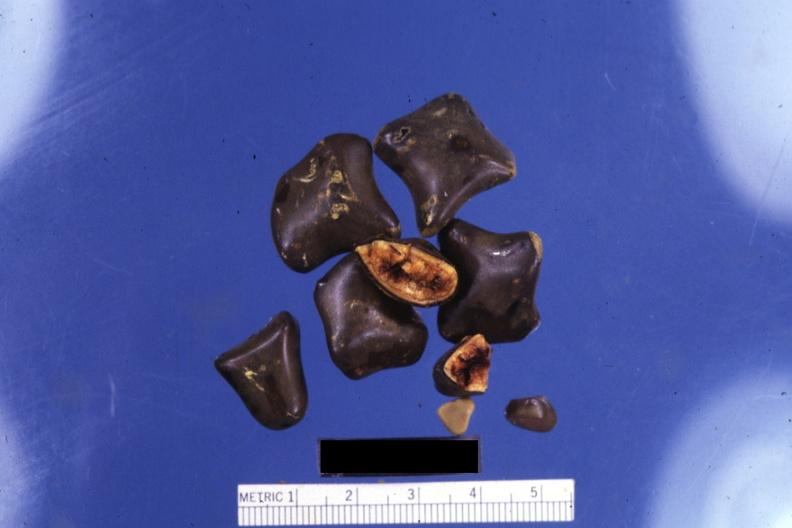s close-up of faceted mixed stones with two showing cut surfaces?
Answer the question using a single word or phrase. Yes 